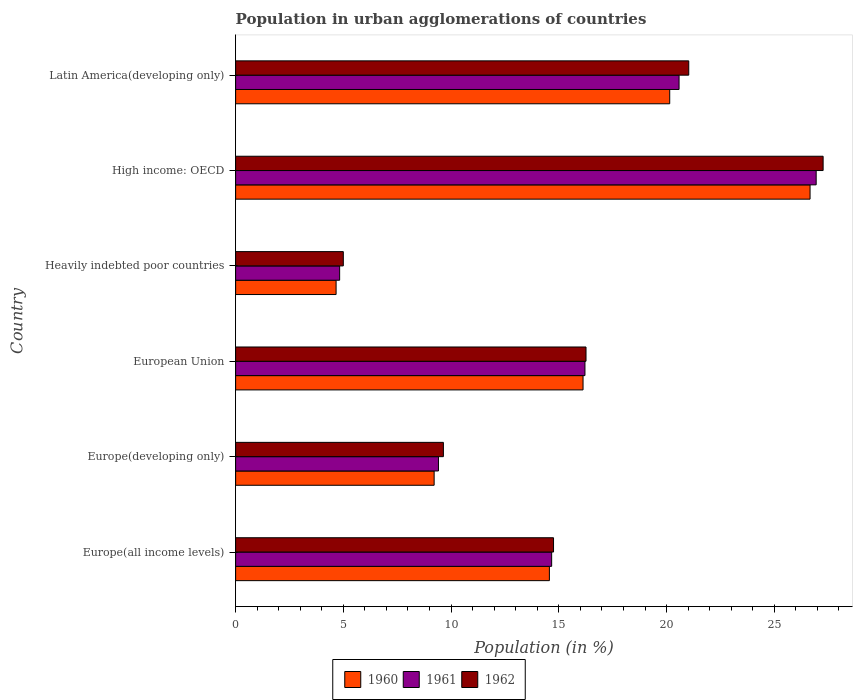How many groups of bars are there?
Give a very brief answer. 6. Are the number of bars per tick equal to the number of legend labels?
Provide a short and direct response. Yes. How many bars are there on the 6th tick from the top?
Your answer should be very brief. 3. What is the label of the 2nd group of bars from the top?
Ensure brevity in your answer.  High income: OECD. What is the percentage of population in urban agglomerations in 1962 in Europe(all income levels)?
Provide a short and direct response. 14.76. Across all countries, what is the maximum percentage of population in urban agglomerations in 1960?
Your answer should be compact. 26.66. Across all countries, what is the minimum percentage of population in urban agglomerations in 1961?
Offer a terse response. 4.83. In which country was the percentage of population in urban agglomerations in 1961 maximum?
Provide a short and direct response. High income: OECD. In which country was the percentage of population in urban agglomerations in 1960 minimum?
Ensure brevity in your answer.  Heavily indebted poor countries. What is the total percentage of population in urban agglomerations in 1962 in the graph?
Your answer should be very brief. 93.96. What is the difference between the percentage of population in urban agglomerations in 1962 in Heavily indebted poor countries and that in High income: OECD?
Offer a very short reply. -22.27. What is the difference between the percentage of population in urban agglomerations in 1960 in European Union and the percentage of population in urban agglomerations in 1961 in Latin America(developing only)?
Your answer should be very brief. -4.46. What is the average percentage of population in urban agglomerations in 1960 per country?
Your response must be concise. 15.23. What is the difference between the percentage of population in urban agglomerations in 1962 and percentage of population in urban agglomerations in 1960 in Europe(all income levels)?
Your answer should be compact. 0.19. In how many countries, is the percentage of population in urban agglomerations in 1961 greater than 1 %?
Offer a very short reply. 6. What is the ratio of the percentage of population in urban agglomerations in 1962 in Europe(all income levels) to that in Europe(developing only)?
Provide a short and direct response. 1.53. Is the percentage of population in urban agglomerations in 1962 in Europe(all income levels) less than that in European Union?
Provide a short and direct response. Yes. What is the difference between the highest and the second highest percentage of population in urban agglomerations in 1961?
Provide a succinct answer. 6.36. What is the difference between the highest and the lowest percentage of population in urban agglomerations in 1960?
Your response must be concise. 22. Is the sum of the percentage of population in urban agglomerations in 1961 in Europe(all income levels) and High income: OECD greater than the maximum percentage of population in urban agglomerations in 1960 across all countries?
Give a very brief answer. Yes. What does the 3rd bar from the bottom in Latin America(developing only) represents?
Offer a very short reply. 1962. How many countries are there in the graph?
Ensure brevity in your answer.  6. What is the difference between two consecutive major ticks on the X-axis?
Your answer should be compact. 5. Are the values on the major ticks of X-axis written in scientific E-notation?
Ensure brevity in your answer.  No. Does the graph contain grids?
Your response must be concise. No. Where does the legend appear in the graph?
Provide a short and direct response. Bottom center. How many legend labels are there?
Offer a terse response. 3. What is the title of the graph?
Provide a succinct answer. Population in urban agglomerations of countries. What is the label or title of the X-axis?
Offer a terse response. Population (in %). What is the Population (in %) of 1960 in Europe(all income levels)?
Offer a very short reply. 14.56. What is the Population (in %) of 1961 in Europe(all income levels)?
Give a very brief answer. 14.67. What is the Population (in %) in 1962 in Europe(all income levels)?
Offer a very short reply. 14.76. What is the Population (in %) in 1960 in Europe(developing only)?
Offer a terse response. 9.21. What is the Population (in %) of 1961 in Europe(developing only)?
Your response must be concise. 9.41. What is the Population (in %) of 1962 in Europe(developing only)?
Provide a succinct answer. 9.64. What is the Population (in %) of 1960 in European Union?
Give a very brief answer. 16.12. What is the Population (in %) in 1961 in European Union?
Give a very brief answer. 16.21. What is the Population (in %) of 1962 in European Union?
Make the answer very short. 16.26. What is the Population (in %) in 1960 in Heavily indebted poor countries?
Your answer should be very brief. 4.66. What is the Population (in %) in 1961 in Heavily indebted poor countries?
Your response must be concise. 4.83. What is the Population (in %) in 1962 in Heavily indebted poor countries?
Offer a terse response. 5. What is the Population (in %) of 1960 in High income: OECD?
Provide a succinct answer. 26.66. What is the Population (in %) in 1961 in High income: OECD?
Your answer should be very brief. 26.94. What is the Population (in %) in 1962 in High income: OECD?
Offer a terse response. 27.27. What is the Population (in %) of 1960 in Latin America(developing only)?
Ensure brevity in your answer.  20.15. What is the Population (in %) in 1961 in Latin America(developing only)?
Your answer should be compact. 20.58. What is the Population (in %) in 1962 in Latin America(developing only)?
Provide a succinct answer. 21.03. Across all countries, what is the maximum Population (in %) in 1960?
Offer a terse response. 26.66. Across all countries, what is the maximum Population (in %) in 1961?
Provide a succinct answer. 26.94. Across all countries, what is the maximum Population (in %) in 1962?
Give a very brief answer. 27.27. Across all countries, what is the minimum Population (in %) in 1960?
Your answer should be very brief. 4.66. Across all countries, what is the minimum Population (in %) of 1961?
Give a very brief answer. 4.83. Across all countries, what is the minimum Population (in %) of 1962?
Your answer should be compact. 5. What is the total Population (in %) of 1960 in the graph?
Offer a terse response. 91.37. What is the total Population (in %) in 1961 in the graph?
Ensure brevity in your answer.  92.65. What is the total Population (in %) in 1962 in the graph?
Make the answer very short. 93.96. What is the difference between the Population (in %) in 1960 in Europe(all income levels) and that in Europe(developing only)?
Give a very brief answer. 5.35. What is the difference between the Population (in %) in 1961 in Europe(all income levels) and that in Europe(developing only)?
Your answer should be very brief. 5.25. What is the difference between the Population (in %) of 1962 in Europe(all income levels) and that in Europe(developing only)?
Offer a terse response. 5.11. What is the difference between the Population (in %) of 1960 in Europe(all income levels) and that in European Union?
Your response must be concise. -1.56. What is the difference between the Population (in %) of 1961 in Europe(all income levels) and that in European Union?
Provide a short and direct response. -1.55. What is the difference between the Population (in %) in 1962 in Europe(all income levels) and that in European Union?
Ensure brevity in your answer.  -1.51. What is the difference between the Population (in %) in 1960 in Europe(all income levels) and that in Heavily indebted poor countries?
Keep it short and to the point. 9.9. What is the difference between the Population (in %) of 1961 in Europe(all income levels) and that in Heavily indebted poor countries?
Provide a succinct answer. 9.84. What is the difference between the Population (in %) in 1962 in Europe(all income levels) and that in Heavily indebted poor countries?
Provide a short and direct response. 9.76. What is the difference between the Population (in %) of 1960 in Europe(all income levels) and that in High income: OECD?
Offer a very short reply. -12.1. What is the difference between the Population (in %) in 1961 in Europe(all income levels) and that in High income: OECD?
Provide a succinct answer. -12.28. What is the difference between the Population (in %) in 1962 in Europe(all income levels) and that in High income: OECD?
Give a very brief answer. -12.51. What is the difference between the Population (in %) of 1960 in Europe(all income levels) and that in Latin America(developing only)?
Your answer should be compact. -5.58. What is the difference between the Population (in %) in 1961 in Europe(all income levels) and that in Latin America(developing only)?
Provide a short and direct response. -5.91. What is the difference between the Population (in %) of 1962 in Europe(all income levels) and that in Latin America(developing only)?
Your answer should be very brief. -6.28. What is the difference between the Population (in %) of 1960 in Europe(developing only) and that in European Union?
Give a very brief answer. -6.91. What is the difference between the Population (in %) of 1961 in Europe(developing only) and that in European Union?
Give a very brief answer. -6.8. What is the difference between the Population (in %) of 1962 in Europe(developing only) and that in European Union?
Make the answer very short. -6.62. What is the difference between the Population (in %) in 1960 in Europe(developing only) and that in Heavily indebted poor countries?
Your answer should be very brief. 4.55. What is the difference between the Population (in %) in 1961 in Europe(developing only) and that in Heavily indebted poor countries?
Your answer should be compact. 4.59. What is the difference between the Population (in %) in 1962 in Europe(developing only) and that in Heavily indebted poor countries?
Give a very brief answer. 4.65. What is the difference between the Population (in %) of 1960 in Europe(developing only) and that in High income: OECD?
Your answer should be very brief. -17.45. What is the difference between the Population (in %) of 1961 in Europe(developing only) and that in High income: OECD?
Your response must be concise. -17.53. What is the difference between the Population (in %) of 1962 in Europe(developing only) and that in High income: OECD?
Your answer should be compact. -17.62. What is the difference between the Population (in %) in 1960 in Europe(developing only) and that in Latin America(developing only)?
Provide a short and direct response. -10.93. What is the difference between the Population (in %) of 1961 in Europe(developing only) and that in Latin America(developing only)?
Ensure brevity in your answer.  -11.17. What is the difference between the Population (in %) in 1962 in Europe(developing only) and that in Latin America(developing only)?
Make the answer very short. -11.39. What is the difference between the Population (in %) in 1960 in European Union and that in Heavily indebted poor countries?
Your answer should be compact. 11.46. What is the difference between the Population (in %) in 1961 in European Union and that in Heavily indebted poor countries?
Make the answer very short. 11.39. What is the difference between the Population (in %) in 1962 in European Union and that in Heavily indebted poor countries?
Ensure brevity in your answer.  11.26. What is the difference between the Population (in %) of 1960 in European Union and that in High income: OECD?
Your answer should be compact. -10.54. What is the difference between the Population (in %) of 1961 in European Union and that in High income: OECD?
Provide a succinct answer. -10.73. What is the difference between the Population (in %) of 1962 in European Union and that in High income: OECD?
Your answer should be very brief. -11. What is the difference between the Population (in %) of 1960 in European Union and that in Latin America(developing only)?
Offer a terse response. -4.02. What is the difference between the Population (in %) in 1961 in European Union and that in Latin America(developing only)?
Offer a very short reply. -4.37. What is the difference between the Population (in %) of 1962 in European Union and that in Latin America(developing only)?
Your response must be concise. -4.77. What is the difference between the Population (in %) in 1960 in Heavily indebted poor countries and that in High income: OECD?
Provide a short and direct response. -22. What is the difference between the Population (in %) in 1961 in Heavily indebted poor countries and that in High income: OECD?
Provide a succinct answer. -22.12. What is the difference between the Population (in %) of 1962 in Heavily indebted poor countries and that in High income: OECD?
Your answer should be very brief. -22.27. What is the difference between the Population (in %) in 1960 in Heavily indebted poor countries and that in Latin America(developing only)?
Offer a terse response. -15.48. What is the difference between the Population (in %) of 1961 in Heavily indebted poor countries and that in Latin America(developing only)?
Give a very brief answer. -15.75. What is the difference between the Population (in %) in 1962 in Heavily indebted poor countries and that in Latin America(developing only)?
Provide a short and direct response. -16.03. What is the difference between the Population (in %) of 1960 in High income: OECD and that in Latin America(developing only)?
Your response must be concise. 6.51. What is the difference between the Population (in %) of 1961 in High income: OECD and that in Latin America(developing only)?
Ensure brevity in your answer.  6.36. What is the difference between the Population (in %) in 1962 in High income: OECD and that in Latin America(developing only)?
Keep it short and to the point. 6.24. What is the difference between the Population (in %) in 1960 in Europe(all income levels) and the Population (in %) in 1961 in Europe(developing only)?
Your answer should be compact. 5.15. What is the difference between the Population (in %) of 1960 in Europe(all income levels) and the Population (in %) of 1962 in Europe(developing only)?
Offer a terse response. 4.92. What is the difference between the Population (in %) in 1961 in Europe(all income levels) and the Population (in %) in 1962 in Europe(developing only)?
Ensure brevity in your answer.  5.02. What is the difference between the Population (in %) of 1960 in Europe(all income levels) and the Population (in %) of 1961 in European Union?
Make the answer very short. -1.65. What is the difference between the Population (in %) in 1960 in Europe(all income levels) and the Population (in %) in 1962 in European Union?
Your response must be concise. -1.7. What is the difference between the Population (in %) of 1961 in Europe(all income levels) and the Population (in %) of 1962 in European Union?
Keep it short and to the point. -1.59. What is the difference between the Population (in %) of 1960 in Europe(all income levels) and the Population (in %) of 1961 in Heavily indebted poor countries?
Make the answer very short. 9.73. What is the difference between the Population (in %) in 1960 in Europe(all income levels) and the Population (in %) in 1962 in Heavily indebted poor countries?
Ensure brevity in your answer.  9.56. What is the difference between the Population (in %) of 1961 in Europe(all income levels) and the Population (in %) of 1962 in Heavily indebted poor countries?
Your answer should be very brief. 9.67. What is the difference between the Population (in %) in 1960 in Europe(all income levels) and the Population (in %) in 1961 in High income: OECD?
Your response must be concise. -12.38. What is the difference between the Population (in %) in 1960 in Europe(all income levels) and the Population (in %) in 1962 in High income: OECD?
Make the answer very short. -12.7. What is the difference between the Population (in %) of 1961 in Europe(all income levels) and the Population (in %) of 1962 in High income: OECD?
Offer a terse response. -12.6. What is the difference between the Population (in %) of 1960 in Europe(all income levels) and the Population (in %) of 1961 in Latin America(developing only)?
Offer a terse response. -6.02. What is the difference between the Population (in %) of 1960 in Europe(all income levels) and the Population (in %) of 1962 in Latin America(developing only)?
Provide a short and direct response. -6.47. What is the difference between the Population (in %) of 1961 in Europe(all income levels) and the Population (in %) of 1962 in Latin America(developing only)?
Your answer should be very brief. -6.36. What is the difference between the Population (in %) in 1960 in Europe(developing only) and the Population (in %) in 1961 in European Union?
Your response must be concise. -7. What is the difference between the Population (in %) in 1960 in Europe(developing only) and the Population (in %) in 1962 in European Union?
Keep it short and to the point. -7.05. What is the difference between the Population (in %) in 1961 in Europe(developing only) and the Population (in %) in 1962 in European Union?
Ensure brevity in your answer.  -6.85. What is the difference between the Population (in %) in 1960 in Europe(developing only) and the Population (in %) in 1961 in Heavily indebted poor countries?
Your answer should be very brief. 4.39. What is the difference between the Population (in %) in 1960 in Europe(developing only) and the Population (in %) in 1962 in Heavily indebted poor countries?
Provide a succinct answer. 4.22. What is the difference between the Population (in %) of 1961 in Europe(developing only) and the Population (in %) of 1962 in Heavily indebted poor countries?
Provide a short and direct response. 4.42. What is the difference between the Population (in %) in 1960 in Europe(developing only) and the Population (in %) in 1961 in High income: OECD?
Give a very brief answer. -17.73. What is the difference between the Population (in %) of 1960 in Europe(developing only) and the Population (in %) of 1962 in High income: OECD?
Your answer should be very brief. -18.05. What is the difference between the Population (in %) of 1961 in Europe(developing only) and the Population (in %) of 1962 in High income: OECD?
Keep it short and to the point. -17.85. What is the difference between the Population (in %) of 1960 in Europe(developing only) and the Population (in %) of 1961 in Latin America(developing only)?
Provide a short and direct response. -11.37. What is the difference between the Population (in %) in 1960 in Europe(developing only) and the Population (in %) in 1962 in Latin America(developing only)?
Provide a short and direct response. -11.82. What is the difference between the Population (in %) in 1961 in Europe(developing only) and the Population (in %) in 1962 in Latin America(developing only)?
Your answer should be compact. -11.62. What is the difference between the Population (in %) of 1960 in European Union and the Population (in %) of 1961 in Heavily indebted poor countries?
Your response must be concise. 11.3. What is the difference between the Population (in %) in 1960 in European Union and the Population (in %) in 1962 in Heavily indebted poor countries?
Your response must be concise. 11.13. What is the difference between the Population (in %) of 1961 in European Union and the Population (in %) of 1962 in Heavily indebted poor countries?
Provide a succinct answer. 11.22. What is the difference between the Population (in %) in 1960 in European Union and the Population (in %) in 1961 in High income: OECD?
Your answer should be very brief. -10.82. What is the difference between the Population (in %) in 1960 in European Union and the Population (in %) in 1962 in High income: OECD?
Keep it short and to the point. -11.14. What is the difference between the Population (in %) in 1961 in European Union and the Population (in %) in 1962 in High income: OECD?
Give a very brief answer. -11.05. What is the difference between the Population (in %) of 1960 in European Union and the Population (in %) of 1961 in Latin America(developing only)?
Keep it short and to the point. -4.46. What is the difference between the Population (in %) of 1960 in European Union and the Population (in %) of 1962 in Latin America(developing only)?
Give a very brief answer. -4.91. What is the difference between the Population (in %) in 1961 in European Union and the Population (in %) in 1962 in Latin America(developing only)?
Provide a short and direct response. -4.82. What is the difference between the Population (in %) in 1960 in Heavily indebted poor countries and the Population (in %) in 1961 in High income: OECD?
Your response must be concise. -22.28. What is the difference between the Population (in %) in 1960 in Heavily indebted poor countries and the Population (in %) in 1962 in High income: OECD?
Offer a very short reply. -22.6. What is the difference between the Population (in %) of 1961 in Heavily indebted poor countries and the Population (in %) of 1962 in High income: OECD?
Give a very brief answer. -22.44. What is the difference between the Population (in %) in 1960 in Heavily indebted poor countries and the Population (in %) in 1961 in Latin America(developing only)?
Your answer should be compact. -15.92. What is the difference between the Population (in %) of 1960 in Heavily indebted poor countries and the Population (in %) of 1962 in Latin America(developing only)?
Your answer should be compact. -16.37. What is the difference between the Population (in %) of 1961 in Heavily indebted poor countries and the Population (in %) of 1962 in Latin America(developing only)?
Give a very brief answer. -16.2. What is the difference between the Population (in %) of 1960 in High income: OECD and the Population (in %) of 1961 in Latin America(developing only)?
Keep it short and to the point. 6.08. What is the difference between the Population (in %) of 1960 in High income: OECD and the Population (in %) of 1962 in Latin America(developing only)?
Provide a short and direct response. 5.63. What is the difference between the Population (in %) in 1961 in High income: OECD and the Population (in %) in 1962 in Latin America(developing only)?
Your response must be concise. 5.91. What is the average Population (in %) in 1960 per country?
Make the answer very short. 15.23. What is the average Population (in %) in 1961 per country?
Make the answer very short. 15.44. What is the average Population (in %) in 1962 per country?
Provide a short and direct response. 15.66. What is the difference between the Population (in %) of 1960 and Population (in %) of 1961 in Europe(all income levels)?
Your answer should be compact. -0.1. What is the difference between the Population (in %) in 1960 and Population (in %) in 1962 in Europe(all income levels)?
Offer a terse response. -0.19. What is the difference between the Population (in %) in 1961 and Population (in %) in 1962 in Europe(all income levels)?
Your answer should be very brief. -0.09. What is the difference between the Population (in %) in 1960 and Population (in %) in 1961 in Europe(developing only)?
Provide a succinct answer. -0.2. What is the difference between the Population (in %) in 1960 and Population (in %) in 1962 in Europe(developing only)?
Offer a terse response. -0.43. What is the difference between the Population (in %) in 1961 and Population (in %) in 1962 in Europe(developing only)?
Provide a succinct answer. -0.23. What is the difference between the Population (in %) in 1960 and Population (in %) in 1961 in European Union?
Provide a succinct answer. -0.09. What is the difference between the Population (in %) in 1960 and Population (in %) in 1962 in European Union?
Offer a very short reply. -0.14. What is the difference between the Population (in %) of 1961 and Population (in %) of 1962 in European Union?
Your answer should be compact. -0.05. What is the difference between the Population (in %) in 1960 and Population (in %) in 1961 in Heavily indebted poor countries?
Provide a succinct answer. -0.16. What is the difference between the Population (in %) in 1960 and Population (in %) in 1962 in Heavily indebted poor countries?
Offer a very short reply. -0.33. What is the difference between the Population (in %) in 1961 and Population (in %) in 1962 in Heavily indebted poor countries?
Provide a succinct answer. -0.17. What is the difference between the Population (in %) in 1960 and Population (in %) in 1961 in High income: OECD?
Offer a very short reply. -0.28. What is the difference between the Population (in %) of 1960 and Population (in %) of 1962 in High income: OECD?
Make the answer very short. -0.61. What is the difference between the Population (in %) in 1961 and Population (in %) in 1962 in High income: OECD?
Ensure brevity in your answer.  -0.32. What is the difference between the Population (in %) in 1960 and Population (in %) in 1961 in Latin America(developing only)?
Make the answer very short. -0.43. What is the difference between the Population (in %) in 1960 and Population (in %) in 1962 in Latin America(developing only)?
Your answer should be compact. -0.88. What is the difference between the Population (in %) of 1961 and Population (in %) of 1962 in Latin America(developing only)?
Ensure brevity in your answer.  -0.45. What is the ratio of the Population (in %) of 1960 in Europe(all income levels) to that in Europe(developing only)?
Make the answer very short. 1.58. What is the ratio of the Population (in %) in 1961 in Europe(all income levels) to that in Europe(developing only)?
Offer a terse response. 1.56. What is the ratio of the Population (in %) in 1962 in Europe(all income levels) to that in Europe(developing only)?
Provide a short and direct response. 1.53. What is the ratio of the Population (in %) in 1960 in Europe(all income levels) to that in European Union?
Ensure brevity in your answer.  0.9. What is the ratio of the Population (in %) in 1961 in Europe(all income levels) to that in European Union?
Your answer should be compact. 0.9. What is the ratio of the Population (in %) of 1962 in Europe(all income levels) to that in European Union?
Make the answer very short. 0.91. What is the ratio of the Population (in %) in 1960 in Europe(all income levels) to that in Heavily indebted poor countries?
Offer a very short reply. 3.12. What is the ratio of the Population (in %) in 1961 in Europe(all income levels) to that in Heavily indebted poor countries?
Provide a short and direct response. 3.04. What is the ratio of the Population (in %) in 1962 in Europe(all income levels) to that in Heavily indebted poor countries?
Your answer should be compact. 2.95. What is the ratio of the Population (in %) in 1960 in Europe(all income levels) to that in High income: OECD?
Your answer should be compact. 0.55. What is the ratio of the Population (in %) of 1961 in Europe(all income levels) to that in High income: OECD?
Provide a short and direct response. 0.54. What is the ratio of the Population (in %) in 1962 in Europe(all income levels) to that in High income: OECD?
Your answer should be very brief. 0.54. What is the ratio of the Population (in %) in 1960 in Europe(all income levels) to that in Latin America(developing only)?
Ensure brevity in your answer.  0.72. What is the ratio of the Population (in %) in 1961 in Europe(all income levels) to that in Latin America(developing only)?
Offer a very short reply. 0.71. What is the ratio of the Population (in %) of 1962 in Europe(all income levels) to that in Latin America(developing only)?
Provide a succinct answer. 0.7. What is the ratio of the Population (in %) of 1961 in Europe(developing only) to that in European Union?
Give a very brief answer. 0.58. What is the ratio of the Population (in %) in 1962 in Europe(developing only) to that in European Union?
Give a very brief answer. 0.59. What is the ratio of the Population (in %) in 1960 in Europe(developing only) to that in Heavily indebted poor countries?
Your answer should be compact. 1.98. What is the ratio of the Population (in %) in 1961 in Europe(developing only) to that in Heavily indebted poor countries?
Your response must be concise. 1.95. What is the ratio of the Population (in %) in 1962 in Europe(developing only) to that in Heavily indebted poor countries?
Offer a very short reply. 1.93. What is the ratio of the Population (in %) of 1960 in Europe(developing only) to that in High income: OECD?
Offer a terse response. 0.35. What is the ratio of the Population (in %) in 1961 in Europe(developing only) to that in High income: OECD?
Your answer should be compact. 0.35. What is the ratio of the Population (in %) in 1962 in Europe(developing only) to that in High income: OECD?
Provide a short and direct response. 0.35. What is the ratio of the Population (in %) in 1960 in Europe(developing only) to that in Latin America(developing only)?
Keep it short and to the point. 0.46. What is the ratio of the Population (in %) in 1961 in Europe(developing only) to that in Latin America(developing only)?
Keep it short and to the point. 0.46. What is the ratio of the Population (in %) of 1962 in Europe(developing only) to that in Latin America(developing only)?
Provide a short and direct response. 0.46. What is the ratio of the Population (in %) of 1960 in European Union to that in Heavily indebted poor countries?
Provide a short and direct response. 3.46. What is the ratio of the Population (in %) in 1961 in European Union to that in Heavily indebted poor countries?
Your response must be concise. 3.36. What is the ratio of the Population (in %) of 1962 in European Union to that in Heavily indebted poor countries?
Your answer should be compact. 3.25. What is the ratio of the Population (in %) in 1960 in European Union to that in High income: OECD?
Provide a succinct answer. 0.6. What is the ratio of the Population (in %) of 1961 in European Union to that in High income: OECD?
Make the answer very short. 0.6. What is the ratio of the Population (in %) of 1962 in European Union to that in High income: OECD?
Keep it short and to the point. 0.6. What is the ratio of the Population (in %) in 1960 in European Union to that in Latin America(developing only)?
Provide a succinct answer. 0.8. What is the ratio of the Population (in %) in 1961 in European Union to that in Latin America(developing only)?
Keep it short and to the point. 0.79. What is the ratio of the Population (in %) in 1962 in European Union to that in Latin America(developing only)?
Offer a very short reply. 0.77. What is the ratio of the Population (in %) of 1960 in Heavily indebted poor countries to that in High income: OECD?
Your response must be concise. 0.17. What is the ratio of the Population (in %) of 1961 in Heavily indebted poor countries to that in High income: OECD?
Keep it short and to the point. 0.18. What is the ratio of the Population (in %) of 1962 in Heavily indebted poor countries to that in High income: OECD?
Provide a short and direct response. 0.18. What is the ratio of the Population (in %) of 1960 in Heavily indebted poor countries to that in Latin America(developing only)?
Offer a very short reply. 0.23. What is the ratio of the Population (in %) in 1961 in Heavily indebted poor countries to that in Latin America(developing only)?
Make the answer very short. 0.23. What is the ratio of the Population (in %) in 1962 in Heavily indebted poor countries to that in Latin America(developing only)?
Give a very brief answer. 0.24. What is the ratio of the Population (in %) of 1960 in High income: OECD to that in Latin America(developing only)?
Offer a very short reply. 1.32. What is the ratio of the Population (in %) in 1961 in High income: OECD to that in Latin America(developing only)?
Your answer should be compact. 1.31. What is the ratio of the Population (in %) in 1962 in High income: OECD to that in Latin America(developing only)?
Your answer should be very brief. 1.3. What is the difference between the highest and the second highest Population (in %) of 1960?
Offer a very short reply. 6.51. What is the difference between the highest and the second highest Population (in %) in 1961?
Make the answer very short. 6.36. What is the difference between the highest and the second highest Population (in %) in 1962?
Offer a terse response. 6.24. What is the difference between the highest and the lowest Population (in %) of 1960?
Give a very brief answer. 22. What is the difference between the highest and the lowest Population (in %) in 1961?
Provide a succinct answer. 22.12. What is the difference between the highest and the lowest Population (in %) in 1962?
Make the answer very short. 22.27. 